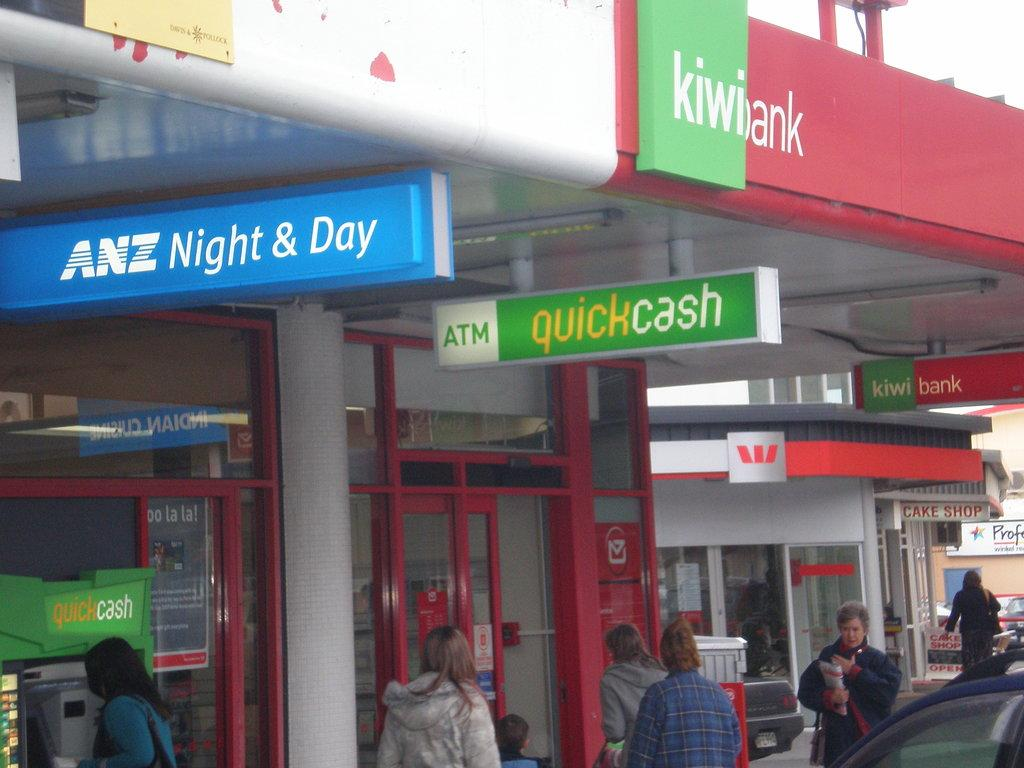What is the name of the building in the image? The building in the image is named "Kiwibank." What can be seen happening in front of the building? There are people walking in front of the building. What verse is being recited by the representative in the image? There is no representative or verse present in the image. 